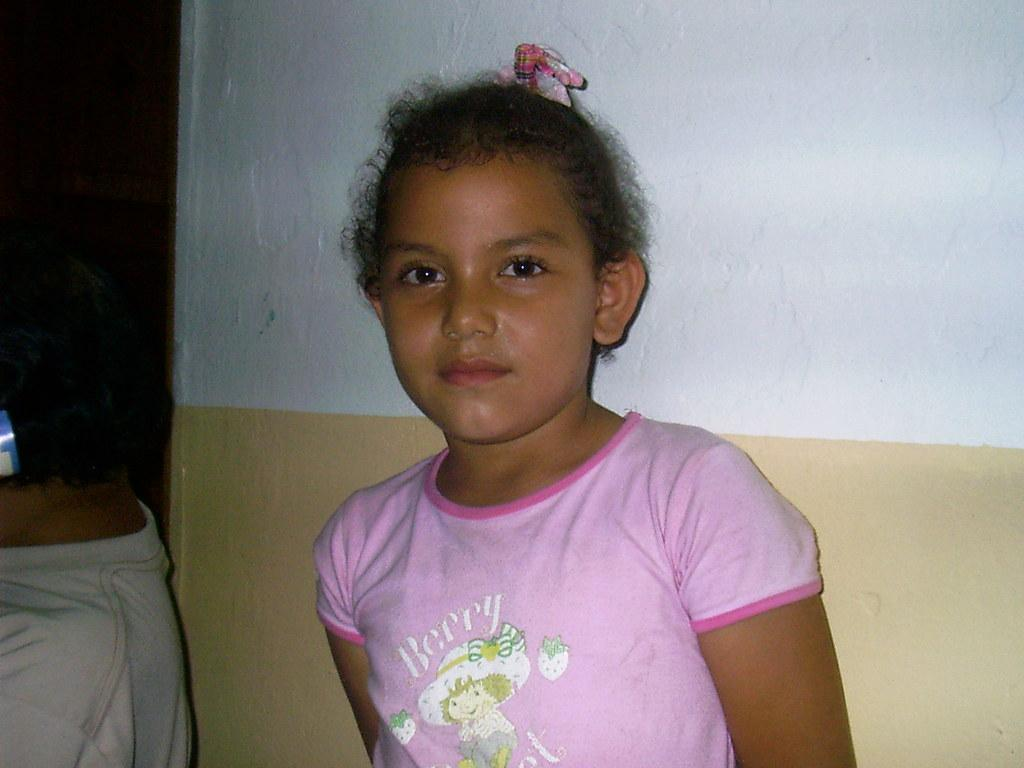How many kids are present in the image? There are two kids in the image. What is visible in the background of the image? There is a wall in the background of the image. How many clovers can be seen in the image? There are no clovers present in the image. What type of grip is being used by the kids in the image? There is no indication of any specific grip being used by the kids in the image. 